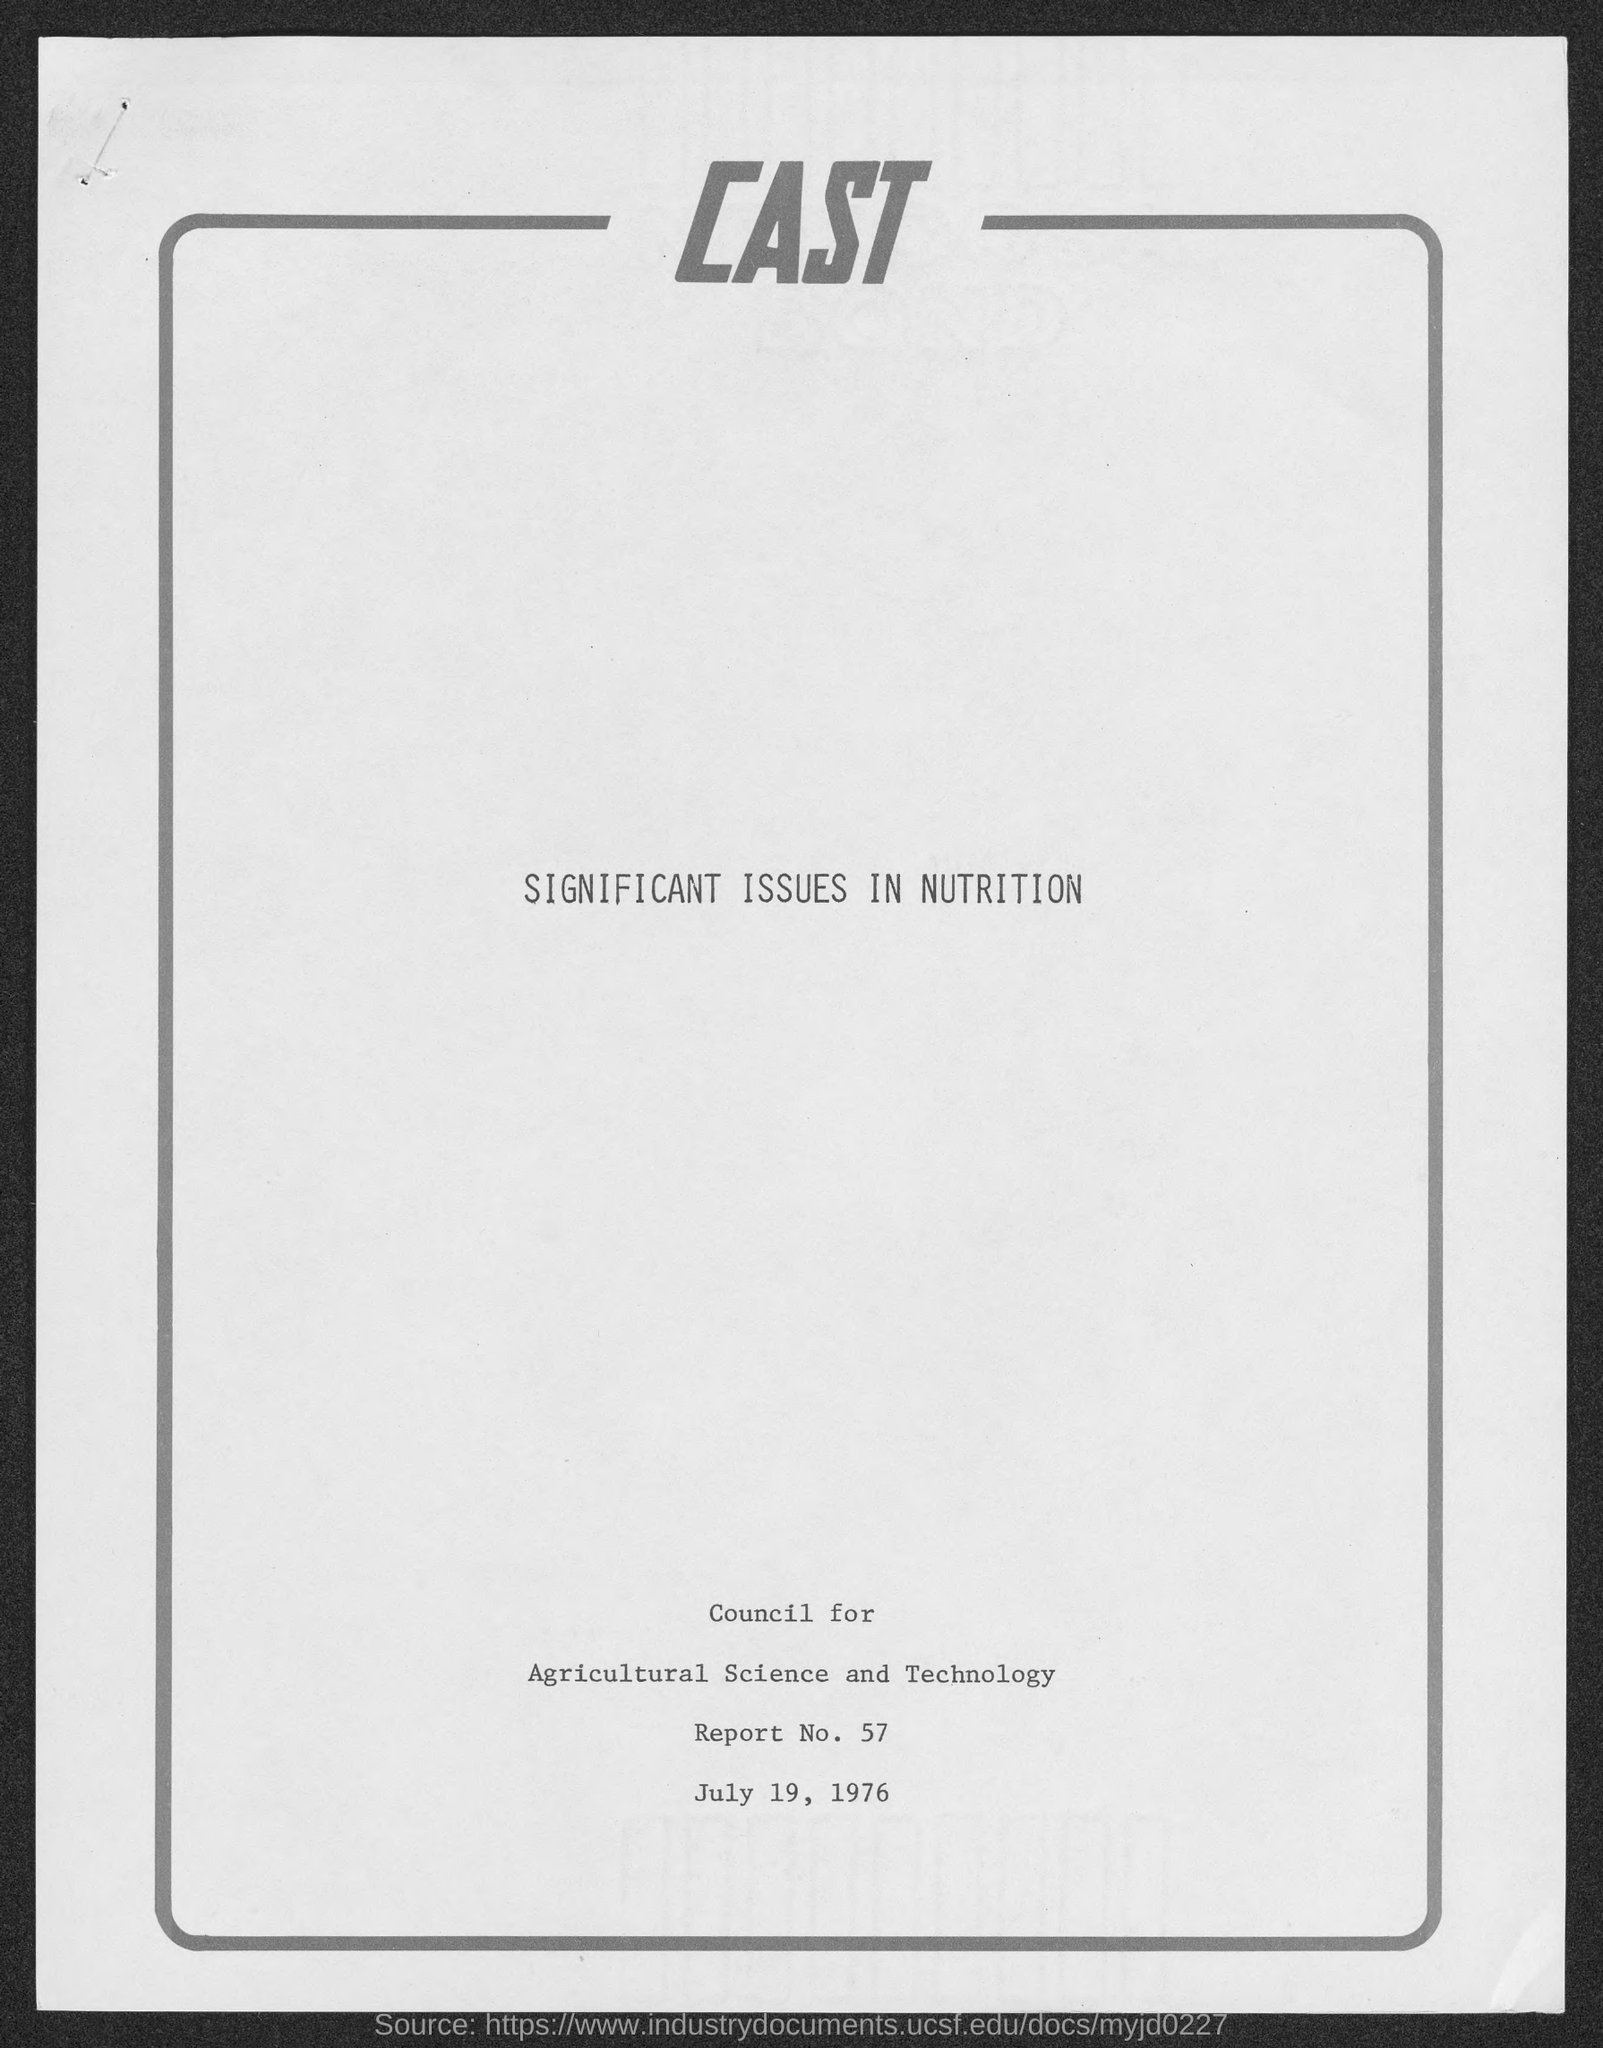When is the Memorandum dated on ?
Ensure brevity in your answer.  July 19, 1976. What is the Report Number ?
Give a very brief answer. Report No. 57. 